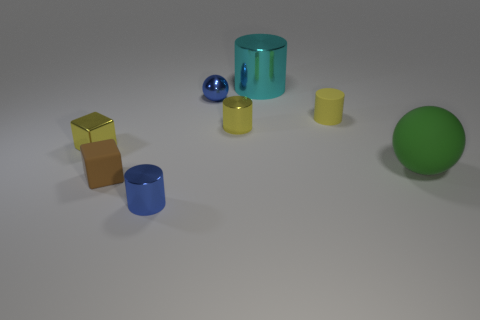What number of other objects are the same color as the large rubber sphere?
Make the answer very short. 0. What is the material of the small brown cube?
Ensure brevity in your answer.  Rubber. Is there a small yellow metal thing?
Offer a very short reply. Yes. Are there the same number of cyan metal things behind the big cyan cylinder and green matte things?
Offer a terse response. No. Is there anything else that has the same material as the brown block?
Offer a very short reply. Yes. What number of tiny objects are either brown rubber objects or yellow metallic blocks?
Ensure brevity in your answer.  2. There is a shiny object that is the same color as the tiny sphere; what is its shape?
Your answer should be compact. Cylinder. Is the material of the thing in front of the brown matte object the same as the brown object?
Offer a terse response. No. What material is the tiny blue object behind the blue metal thing in front of the big green ball made of?
Give a very brief answer. Metal. How many green objects are the same shape as the cyan object?
Provide a short and direct response. 0. 